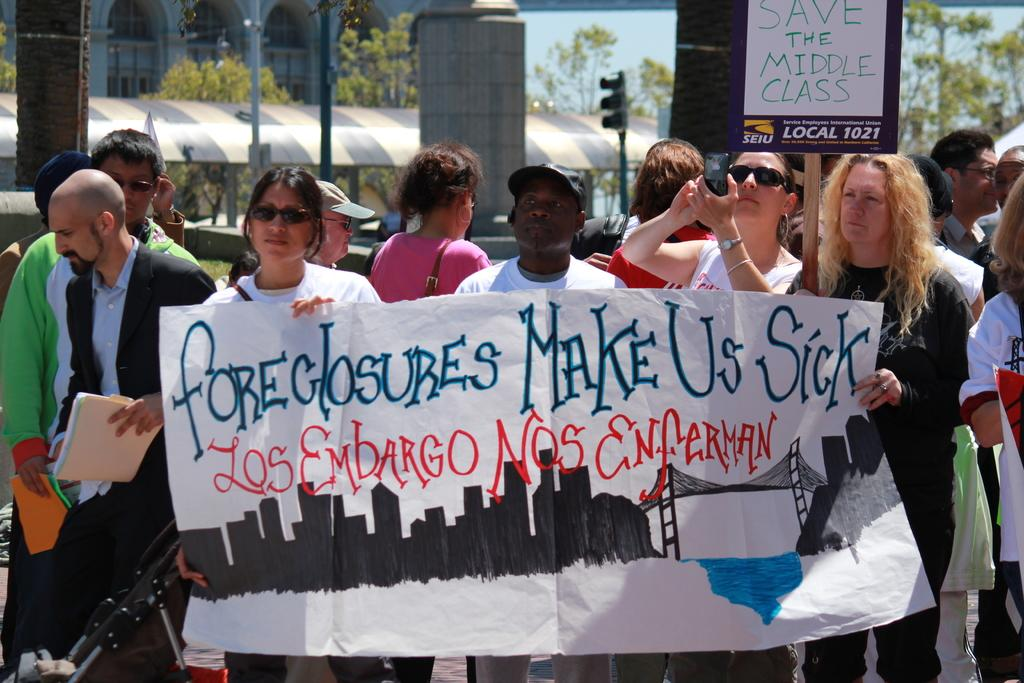What are the people in the image holding? The people in the image are holding banners. What else can be seen in the image besides the people holding banners? There is a placard in the image. What can be seen in the background of the image? In the background of the image, there are traffic lights, buildings, and trees. What type of pancake is being served at the event in the image? There is no pancake present in the image, and no event is mentioned. Which type of berry is being used to decorate the placard in the image? There are no berries present in the image, and the placard does not appear to be decorated with any fruits. 